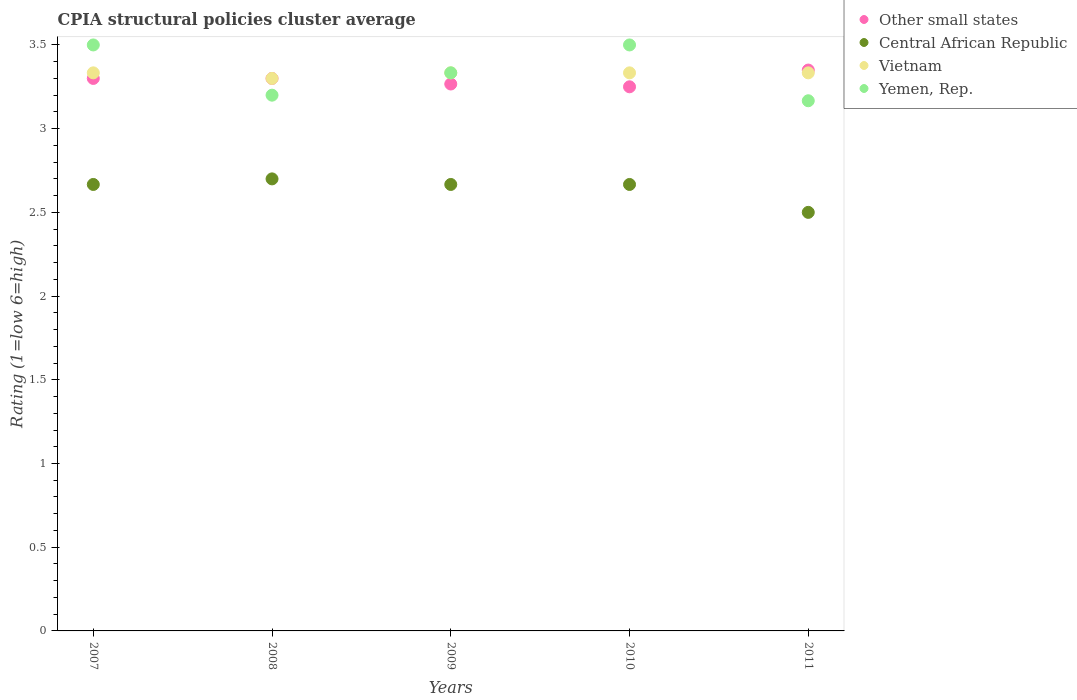How many different coloured dotlines are there?
Give a very brief answer. 4. Is the number of dotlines equal to the number of legend labels?
Offer a terse response. Yes. What is the CPIA rating in Other small states in 2011?
Provide a short and direct response. 3.35. Across all years, what is the maximum CPIA rating in Vietnam?
Offer a terse response. 3.33. Across all years, what is the minimum CPIA rating in Yemen, Rep.?
Ensure brevity in your answer.  3.17. In which year was the CPIA rating in Other small states minimum?
Your answer should be very brief. 2010. What is the difference between the CPIA rating in Other small states in 2007 and that in 2011?
Provide a short and direct response. -0.05. What is the difference between the CPIA rating in Vietnam in 2010 and the CPIA rating in Central African Republic in 2008?
Give a very brief answer. 0.63. What is the average CPIA rating in Other small states per year?
Your answer should be very brief. 3.29. In the year 2008, what is the difference between the CPIA rating in Other small states and CPIA rating in Central African Republic?
Offer a very short reply. 0.6. In how many years, is the CPIA rating in Other small states greater than 3?
Your answer should be compact. 5. What is the ratio of the CPIA rating in Central African Republic in 2008 to that in 2010?
Provide a short and direct response. 1.01. Is the CPIA rating in Other small states in 2007 less than that in 2009?
Offer a very short reply. No. What is the difference between the highest and the lowest CPIA rating in Yemen, Rep.?
Provide a succinct answer. 0.33. In how many years, is the CPIA rating in Yemen, Rep. greater than the average CPIA rating in Yemen, Rep. taken over all years?
Your answer should be very brief. 2. Is it the case that in every year, the sum of the CPIA rating in Vietnam and CPIA rating in Central African Republic  is greater than the CPIA rating in Other small states?
Offer a terse response. Yes. Does the CPIA rating in Yemen, Rep. monotonically increase over the years?
Offer a terse response. No. How many dotlines are there?
Provide a succinct answer. 4. What is the difference between two consecutive major ticks on the Y-axis?
Ensure brevity in your answer.  0.5. Does the graph contain grids?
Your response must be concise. No. What is the title of the graph?
Your response must be concise. CPIA structural policies cluster average. Does "Liechtenstein" appear as one of the legend labels in the graph?
Your answer should be compact. No. What is the label or title of the Y-axis?
Your response must be concise. Rating (1=low 6=high). What is the Rating (1=low 6=high) of Other small states in 2007?
Make the answer very short. 3.3. What is the Rating (1=low 6=high) of Central African Republic in 2007?
Offer a very short reply. 2.67. What is the Rating (1=low 6=high) of Vietnam in 2007?
Make the answer very short. 3.33. What is the Rating (1=low 6=high) of Other small states in 2008?
Provide a succinct answer. 3.3. What is the Rating (1=low 6=high) in Yemen, Rep. in 2008?
Offer a very short reply. 3.2. What is the Rating (1=low 6=high) of Other small states in 2009?
Your answer should be compact. 3.27. What is the Rating (1=low 6=high) of Central African Republic in 2009?
Offer a terse response. 2.67. What is the Rating (1=low 6=high) of Vietnam in 2009?
Ensure brevity in your answer.  3.33. What is the Rating (1=low 6=high) in Yemen, Rep. in 2009?
Your response must be concise. 3.33. What is the Rating (1=low 6=high) in Other small states in 2010?
Your answer should be compact. 3.25. What is the Rating (1=low 6=high) in Central African Republic in 2010?
Keep it short and to the point. 2.67. What is the Rating (1=low 6=high) in Vietnam in 2010?
Keep it short and to the point. 3.33. What is the Rating (1=low 6=high) of Yemen, Rep. in 2010?
Keep it short and to the point. 3.5. What is the Rating (1=low 6=high) of Other small states in 2011?
Give a very brief answer. 3.35. What is the Rating (1=low 6=high) of Central African Republic in 2011?
Your answer should be compact. 2.5. What is the Rating (1=low 6=high) in Vietnam in 2011?
Keep it short and to the point. 3.33. What is the Rating (1=low 6=high) of Yemen, Rep. in 2011?
Your response must be concise. 3.17. Across all years, what is the maximum Rating (1=low 6=high) of Other small states?
Your response must be concise. 3.35. Across all years, what is the maximum Rating (1=low 6=high) of Vietnam?
Ensure brevity in your answer.  3.33. Across all years, what is the minimum Rating (1=low 6=high) of Other small states?
Your answer should be compact. 3.25. Across all years, what is the minimum Rating (1=low 6=high) in Vietnam?
Ensure brevity in your answer.  3.3. Across all years, what is the minimum Rating (1=low 6=high) in Yemen, Rep.?
Make the answer very short. 3.17. What is the total Rating (1=low 6=high) of Other small states in the graph?
Your answer should be very brief. 16.47. What is the total Rating (1=low 6=high) in Vietnam in the graph?
Offer a very short reply. 16.63. What is the difference between the Rating (1=low 6=high) in Other small states in 2007 and that in 2008?
Your answer should be compact. 0. What is the difference between the Rating (1=low 6=high) of Central African Republic in 2007 and that in 2008?
Make the answer very short. -0.03. What is the difference between the Rating (1=low 6=high) in Other small states in 2007 and that in 2009?
Offer a terse response. 0.03. What is the difference between the Rating (1=low 6=high) in Central African Republic in 2007 and that in 2009?
Your response must be concise. 0. What is the difference between the Rating (1=low 6=high) in Vietnam in 2007 and that in 2009?
Your response must be concise. 0. What is the difference between the Rating (1=low 6=high) of Yemen, Rep. in 2007 and that in 2009?
Your answer should be compact. 0.17. What is the difference between the Rating (1=low 6=high) of Vietnam in 2007 and that in 2010?
Your response must be concise. 0. What is the difference between the Rating (1=low 6=high) in Yemen, Rep. in 2007 and that in 2010?
Offer a very short reply. 0. What is the difference between the Rating (1=low 6=high) in Vietnam in 2007 and that in 2011?
Your answer should be compact. 0. What is the difference between the Rating (1=low 6=high) of Yemen, Rep. in 2007 and that in 2011?
Ensure brevity in your answer.  0.33. What is the difference between the Rating (1=low 6=high) in Central African Republic in 2008 and that in 2009?
Give a very brief answer. 0.03. What is the difference between the Rating (1=low 6=high) of Vietnam in 2008 and that in 2009?
Ensure brevity in your answer.  -0.03. What is the difference between the Rating (1=low 6=high) in Yemen, Rep. in 2008 and that in 2009?
Keep it short and to the point. -0.13. What is the difference between the Rating (1=low 6=high) in Other small states in 2008 and that in 2010?
Your response must be concise. 0.05. What is the difference between the Rating (1=low 6=high) in Vietnam in 2008 and that in 2010?
Your answer should be very brief. -0.03. What is the difference between the Rating (1=low 6=high) in Other small states in 2008 and that in 2011?
Make the answer very short. -0.05. What is the difference between the Rating (1=low 6=high) in Central African Republic in 2008 and that in 2011?
Offer a very short reply. 0.2. What is the difference between the Rating (1=low 6=high) in Vietnam in 2008 and that in 2011?
Provide a succinct answer. -0.03. What is the difference between the Rating (1=low 6=high) in Other small states in 2009 and that in 2010?
Offer a very short reply. 0.02. What is the difference between the Rating (1=low 6=high) in Central African Republic in 2009 and that in 2010?
Your answer should be compact. 0. What is the difference between the Rating (1=low 6=high) of Yemen, Rep. in 2009 and that in 2010?
Keep it short and to the point. -0.17. What is the difference between the Rating (1=low 6=high) in Other small states in 2009 and that in 2011?
Ensure brevity in your answer.  -0.08. What is the difference between the Rating (1=low 6=high) in Central African Republic in 2009 and that in 2011?
Make the answer very short. 0.17. What is the difference between the Rating (1=low 6=high) of Yemen, Rep. in 2009 and that in 2011?
Offer a terse response. 0.17. What is the difference between the Rating (1=low 6=high) in Vietnam in 2010 and that in 2011?
Your response must be concise. 0. What is the difference between the Rating (1=low 6=high) of Other small states in 2007 and the Rating (1=low 6=high) of Yemen, Rep. in 2008?
Your answer should be very brief. 0.1. What is the difference between the Rating (1=low 6=high) of Central African Republic in 2007 and the Rating (1=low 6=high) of Vietnam in 2008?
Offer a very short reply. -0.63. What is the difference between the Rating (1=low 6=high) in Central African Republic in 2007 and the Rating (1=low 6=high) in Yemen, Rep. in 2008?
Your answer should be very brief. -0.53. What is the difference between the Rating (1=low 6=high) in Vietnam in 2007 and the Rating (1=low 6=high) in Yemen, Rep. in 2008?
Your answer should be very brief. 0.13. What is the difference between the Rating (1=low 6=high) of Other small states in 2007 and the Rating (1=low 6=high) of Central African Republic in 2009?
Offer a terse response. 0.63. What is the difference between the Rating (1=low 6=high) in Other small states in 2007 and the Rating (1=low 6=high) in Vietnam in 2009?
Provide a short and direct response. -0.03. What is the difference between the Rating (1=low 6=high) of Other small states in 2007 and the Rating (1=low 6=high) of Yemen, Rep. in 2009?
Your response must be concise. -0.03. What is the difference between the Rating (1=low 6=high) of Other small states in 2007 and the Rating (1=low 6=high) of Central African Republic in 2010?
Provide a short and direct response. 0.63. What is the difference between the Rating (1=low 6=high) in Other small states in 2007 and the Rating (1=low 6=high) in Vietnam in 2010?
Offer a very short reply. -0.03. What is the difference between the Rating (1=low 6=high) in Other small states in 2007 and the Rating (1=low 6=high) in Yemen, Rep. in 2010?
Make the answer very short. -0.2. What is the difference between the Rating (1=low 6=high) of Central African Republic in 2007 and the Rating (1=low 6=high) of Vietnam in 2010?
Your response must be concise. -0.67. What is the difference between the Rating (1=low 6=high) of Vietnam in 2007 and the Rating (1=low 6=high) of Yemen, Rep. in 2010?
Give a very brief answer. -0.17. What is the difference between the Rating (1=low 6=high) of Other small states in 2007 and the Rating (1=low 6=high) of Central African Republic in 2011?
Your response must be concise. 0.8. What is the difference between the Rating (1=low 6=high) of Other small states in 2007 and the Rating (1=low 6=high) of Vietnam in 2011?
Provide a succinct answer. -0.03. What is the difference between the Rating (1=low 6=high) of Other small states in 2007 and the Rating (1=low 6=high) of Yemen, Rep. in 2011?
Offer a terse response. 0.13. What is the difference between the Rating (1=low 6=high) in Central African Republic in 2007 and the Rating (1=low 6=high) in Vietnam in 2011?
Provide a short and direct response. -0.67. What is the difference between the Rating (1=low 6=high) of Other small states in 2008 and the Rating (1=low 6=high) of Central African Republic in 2009?
Ensure brevity in your answer.  0.63. What is the difference between the Rating (1=low 6=high) in Other small states in 2008 and the Rating (1=low 6=high) in Vietnam in 2009?
Offer a terse response. -0.03. What is the difference between the Rating (1=low 6=high) in Other small states in 2008 and the Rating (1=low 6=high) in Yemen, Rep. in 2009?
Give a very brief answer. -0.03. What is the difference between the Rating (1=low 6=high) of Central African Republic in 2008 and the Rating (1=low 6=high) of Vietnam in 2009?
Your answer should be compact. -0.63. What is the difference between the Rating (1=low 6=high) in Central African Republic in 2008 and the Rating (1=low 6=high) in Yemen, Rep. in 2009?
Provide a succinct answer. -0.63. What is the difference between the Rating (1=low 6=high) in Vietnam in 2008 and the Rating (1=low 6=high) in Yemen, Rep. in 2009?
Provide a succinct answer. -0.03. What is the difference between the Rating (1=low 6=high) in Other small states in 2008 and the Rating (1=low 6=high) in Central African Republic in 2010?
Offer a very short reply. 0.63. What is the difference between the Rating (1=low 6=high) in Other small states in 2008 and the Rating (1=low 6=high) in Vietnam in 2010?
Provide a short and direct response. -0.03. What is the difference between the Rating (1=low 6=high) of Central African Republic in 2008 and the Rating (1=low 6=high) of Vietnam in 2010?
Provide a succinct answer. -0.63. What is the difference between the Rating (1=low 6=high) in Other small states in 2008 and the Rating (1=low 6=high) in Central African Republic in 2011?
Keep it short and to the point. 0.8. What is the difference between the Rating (1=low 6=high) of Other small states in 2008 and the Rating (1=low 6=high) of Vietnam in 2011?
Provide a short and direct response. -0.03. What is the difference between the Rating (1=low 6=high) of Other small states in 2008 and the Rating (1=low 6=high) of Yemen, Rep. in 2011?
Your answer should be very brief. 0.13. What is the difference between the Rating (1=low 6=high) in Central African Republic in 2008 and the Rating (1=low 6=high) in Vietnam in 2011?
Your answer should be very brief. -0.63. What is the difference between the Rating (1=low 6=high) in Central African Republic in 2008 and the Rating (1=low 6=high) in Yemen, Rep. in 2011?
Your response must be concise. -0.47. What is the difference between the Rating (1=low 6=high) of Vietnam in 2008 and the Rating (1=low 6=high) of Yemen, Rep. in 2011?
Your answer should be compact. 0.13. What is the difference between the Rating (1=low 6=high) of Other small states in 2009 and the Rating (1=low 6=high) of Central African Republic in 2010?
Provide a short and direct response. 0.6. What is the difference between the Rating (1=low 6=high) of Other small states in 2009 and the Rating (1=low 6=high) of Vietnam in 2010?
Give a very brief answer. -0.07. What is the difference between the Rating (1=low 6=high) in Other small states in 2009 and the Rating (1=low 6=high) in Yemen, Rep. in 2010?
Ensure brevity in your answer.  -0.23. What is the difference between the Rating (1=low 6=high) of Central African Republic in 2009 and the Rating (1=low 6=high) of Vietnam in 2010?
Offer a very short reply. -0.67. What is the difference between the Rating (1=low 6=high) in Central African Republic in 2009 and the Rating (1=low 6=high) in Yemen, Rep. in 2010?
Your answer should be compact. -0.83. What is the difference between the Rating (1=low 6=high) in Vietnam in 2009 and the Rating (1=low 6=high) in Yemen, Rep. in 2010?
Your response must be concise. -0.17. What is the difference between the Rating (1=low 6=high) of Other small states in 2009 and the Rating (1=low 6=high) of Central African Republic in 2011?
Your answer should be very brief. 0.77. What is the difference between the Rating (1=low 6=high) of Other small states in 2009 and the Rating (1=low 6=high) of Vietnam in 2011?
Your answer should be very brief. -0.07. What is the difference between the Rating (1=low 6=high) of Other small states in 2009 and the Rating (1=low 6=high) of Yemen, Rep. in 2011?
Make the answer very short. 0.1. What is the difference between the Rating (1=low 6=high) in Vietnam in 2009 and the Rating (1=low 6=high) in Yemen, Rep. in 2011?
Your answer should be very brief. 0.17. What is the difference between the Rating (1=low 6=high) of Other small states in 2010 and the Rating (1=low 6=high) of Central African Republic in 2011?
Provide a short and direct response. 0.75. What is the difference between the Rating (1=low 6=high) in Other small states in 2010 and the Rating (1=low 6=high) in Vietnam in 2011?
Your response must be concise. -0.08. What is the difference between the Rating (1=low 6=high) in Other small states in 2010 and the Rating (1=low 6=high) in Yemen, Rep. in 2011?
Provide a short and direct response. 0.08. What is the difference between the Rating (1=low 6=high) of Central African Republic in 2010 and the Rating (1=low 6=high) of Vietnam in 2011?
Keep it short and to the point. -0.67. What is the difference between the Rating (1=low 6=high) of Central African Republic in 2010 and the Rating (1=low 6=high) of Yemen, Rep. in 2011?
Keep it short and to the point. -0.5. What is the difference between the Rating (1=low 6=high) in Vietnam in 2010 and the Rating (1=low 6=high) in Yemen, Rep. in 2011?
Give a very brief answer. 0.17. What is the average Rating (1=low 6=high) in Other small states per year?
Provide a succinct answer. 3.29. What is the average Rating (1=low 6=high) of Central African Republic per year?
Give a very brief answer. 2.64. What is the average Rating (1=low 6=high) of Vietnam per year?
Offer a very short reply. 3.33. What is the average Rating (1=low 6=high) of Yemen, Rep. per year?
Your answer should be compact. 3.34. In the year 2007, what is the difference between the Rating (1=low 6=high) in Other small states and Rating (1=low 6=high) in Central African Republic?
Offer a terse response. 0.63. In the year 2007, what is the difference between the Rating (1=low 6=high) of Other small states and Rating (1=low 6=high) of Vietnam?
Make the answer very short. -0.03. In the year 2007, what is the difference between the Rating (1=low 6=high) in Central African Republic and Rating (1=low 6=high) in Vietnam?
Your answer should be very brief. -0.67. In the year 2007, what is the difference between the Rating (1=low 6=high) in Vietnam and Rating (1=low 6=high) in Yemen, Rep.?
Keep it short and to the point. -0.17. In the year 2008, what is the difference between the Rating (1=low 6=high) of Other small states and Rating (1=low 6=high) of Central African Republic?
Provide a short and direct response. 0.6. In the year 2008, what is the difference between the Rating (1=low 6=high) in Other small states and Rating (1=low 6=high) in Vietnam?
Offer a very short reply. 0. In the year 2008, what is the difference between the Rating (1=low 6=high) in Central African Republic and Rating (1=low 6=high) in Vietnam?
Give a very brief answer. -0.6. In the year 2009, what is the difference between the Rating (1=low 6=high) in Other small states and Rating (1=low 6=high) in Vietnam?
Your response must be concise. -0.07. In the year 2009, what is the difference between the Rating (1=low 6=high) in Other small states and Rating (1=low 6=high) in Yemen, Rep.?
Make the answer very short. -0.07. In the year 2009, what is the difference between the Rating (1=low 6=high) of Central African Republic and Rating (1=low 6=high) of Vietnam?
Offer a terse response. -0.67. In the year 2009, what is the difference between the Rating (1=low 6=high) in Central African Republic and Rating (1=low 6=high) in Yemen, Rep.?
Provide a short and direct response. -0.67. In the year 2009, what is the difference between the Rating (1=low 6=high) in Vietnam and Rating (1=low 6=high) in Yemen, Rep.?
Ensure brevity in your answer.  0. In the year 2010, what is the difference between the Rating (1=low 6=high) in Other small states and Rating (1=low 6=high) in Central African Republic?
Your response must be concise. 0.58. In the year 2010, what is the difference between the Rating (1=low 6=high) in Other small states and Rating (1=low 6=high) in Vietnam?
Provide a succinct answer. -0.08. In the year 2010, what is the difference between the Rating (1=low 6=high) of Other small states and Rating (1=low 6=high) of Yemen, Rep.?
Offer a terse response. -0.25. In the year 2010, what is the difference between the Rating (1=low 6=high) of Central African Republic and Rating (1=low 6=high) of Vietnam?
Your answer should be very brief. -0.67. In the year 2011, what is the difference between the Rating (1=low 6=high) of Other small states and Rating (1=low 6=high) of Central African Republic?
Keep it short and to the point. 0.85. In the year 2011, what is the difference between the Rating (1=low 6=high) in Other small states and Rating (1=low 6=high) in Vietnam?
Your answer should be very brief. 0.02. In the year 2011, what is the difference between the Rating (1=low 6=high) in Other small states and Rating (1=low 6=high) in Yemen, Rep.?
Offer a terse response. 0.18. In the year 2011, what is the difference between the Rating (1=low 6=high) in Central African Republic and Rating (1=low 6=high) in Vietnam?
Make the answer very short. -0.83. In the year 2011, what is the difference between the Rating (1=low 6=high) in Central African Republic and Rating (1=low 6=high) in Yemen, Rep.?
Your response must be concise. -0.67. In the year 2011, what is the difference between the Rating (1=low 6=high) of Vietnam and Rating (1=low 6=high) of Yemen, Rep.?
Offer a very short reply. 0.17. What is the ratio of the Rating (1=low 6=high) in Yemen, Rep. in 2007 to that in 2008?
Your answer should be very brief. 1.09. What is the ratio of the Rating (1=low 6=high) in Other small states in 2007 to that in 2009?
Offer a terse response. 1.01. What is the ratio of the Rating (1=low 6=high) in Central African Republic in 2007 to that in 2009?
Provide a succinct answer. 1. What is the ratio of the Rating (1=low 6=high) in Vietnam in 2007 to that in 2009?
Your answer should be very brief. 1. What is the ratio of the Rating (1=low 6=high) of Other small states in 2007 to that in 2010?
Make the answer very short. 1.02. What is the ratio of the Rating (1=low 6=high) of Central African Republic in 2007 to that in 2010?
Your answer should be very brief. 1. What is the ratio of the Rating (1=low 6=high) in Vietnam in 2007 to that in 2010?
Offer a very short reply. 1. What is the ratio of the Rating (1=low 6=high) in Other small states in 2007 to that in 2011?
Give a very brief answer. 0.99. What is the ratio of the Rating (1=low 6=high) of Central African Republic in 2007 to that in 2011?
Provide a succinct answer. 1.07. What is the ratio of the Rating (1=low 6=high) of Vietnam in 2007 to that in 2011?
Provide a succinct answer. 1. What is the ratio of the Rating (1=low 6=high) of Yemen, Rep. in 2007 to that in 2011?
Give a very brief answer. 1.11. What is the ratio of the Rating (1=low 6=high) of Other small states in 2008 to that in 2009?
Offer a very short reply. 1.01. What is the ratio of the Rating (1=low 6=high) of Central African Republic in 2008 to that in 2009?
Your response must be concise. 1.01. What is the ratio of the Rating (1=low 6=high) in Vietnam in 2008 to that in 2009?
Offer a terse response. 0.99. What is the ratio of the Rating (1=low 6=high) in Yemen, Rep. in 2008 to that in 2009?
Give a very brief answer. 0.96. What is the ratio of the Rating (1=low 6=high) of Other small states in 2008 to that in 2010?
Your response must be concise. 1.02. What is the ratio of the Rating (1=low 6=high) in Central African Republic in 2008 to that in 2010?
Provide a succinct answer. 1.01. What is the ratio of the Rating (1=low 6=high) of Yemen, Rep. in 2008 to that in 2010?
Provide a succinct answer. 0.91. What is the ratio of the Rating (1=low 6=high) of Other small states in 2008 to that in 2011?
Keep it short and to the point. 0.99. What is the ratio of the Rating (1=low 6=high) in Yemen, Rep. in 2008 to that in 2011?
Provide a succinct answer. 1.01. What is the ratio of the Rating (1=low 6=high) of Central African Republic in 2009 to that in 2010?
Make the answer very short. 1. What is the ratio of the Rating (1=low 6=high) of Other small states in 2009 to that in 2011?
Your response must be concise. 0.98. What is the ratio of the Rating (1=low 6=high) in Central African Republic in 2009 to that in 2011?
Your answer should be compact. 1.07. What is the ratio of the Rating (1=low 6=high) of Yemen, Rep. in 2009 to that in 2011?
Make the answer very short. 1.05. What is the ratio of the Rating (1=low 6=high) in Other small states in 2010 to that in 2011?
Offer a terse response. 0.97. What is the ratio of the Rating (1=low 6=high) in Central African Republic in 2010 to that in 2011?
Your answer should be compact. 1.07. What is the ratio of the Rating (1=low 6=high) of Yemen, Rep. in 2010 to that in 2011?
Your answer should be very brief. 1.11. What is the difference between the highest and the second highest Rating (1=low 6=high) in Other small states?
Make the answer very short. 0.05. What is the difference between the highest and the second highest Rating (1=low 6=high) of Central African Republic?
Ensure brevity in your answer.  0.03. What is the difference between the highest and the second highest Rating (1=low 6=high) in Vietnam?
Offer a very short reply. 0. What is the difference between the highest and the lowest Rating (1=low 6=high) in Other small states?
Offer a terse response. 0.1. What is the difference between the highest and the lowest Rating (1=low 6=high) of Central African Republic?
Make the answer very short. 0.2. 